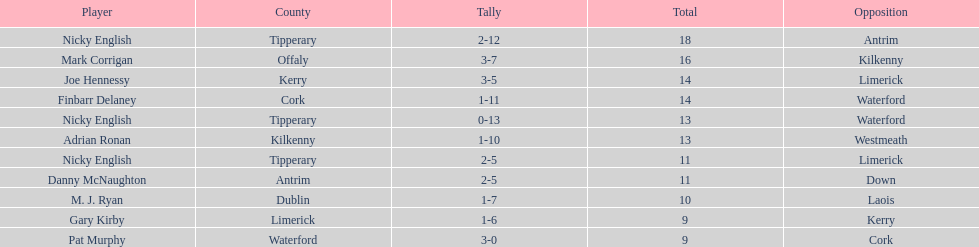How many instances was waterford the opposing side? 2. 